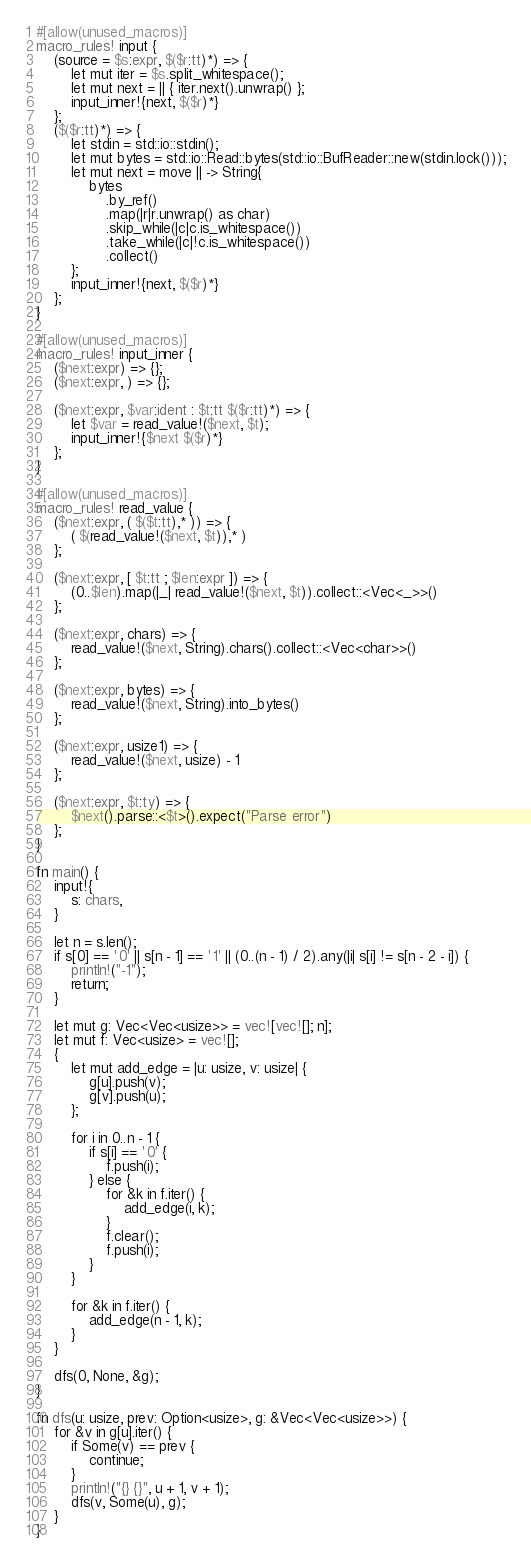<code> <loc_0><loc_0><loc_500><loc_500><_Rust_>#[allow(unused_macros)]
macro_rules! input {
    (source = $s:expr, $($r:tt)*) => {
        let mut iter = $s.split_whitespace();
        let mut next = || { iter.next().unwrap() };
        input_inner!{next, $($r)*}
    };
    ($($r:tt)*) => {
        let stdin = std::io::stdin();
        let mut bytes = std::io::Read::bytes(std::io::BufReader::new(stdin.lock()));
        let mut next = move || -> String{
            bytes
                .by_ref()
                .map(|r|r.unwrap() as char)
                .skip_while(|c|c.is_whitespace())
                .take_while(|c|!c.is_whitespace())
                .collect()
        };
        input_inner!{next, $($r)*}
    };
}

#[allow(unused_macros)]
macro_rules! input_inner {
    ($next:expr) => {};
    ($next:expr, ) => {};

    ($next:expr, $var:ident : $t:tt $($r:tt)*) => {
        let $var = read_value!($next, $t);
        input_inner!{$next $($r)*}
    };
}

#[allow(unused_macros)]
macro_rules! read_value {
    ($next:expr, ( $($t:tt),* )) => {
        ( $(read_value!($next, $t)),* )
    };

    ($next:expr, [ $t:tt ; $len:expr ]) => {
        (0..$len).map(|_| read_value!($next, $t)).collect::<Vec<_>>()
    };

    ($next:expr, chars) => {
        read_value!($next, String).chars().collect::<Vec<char>>()
    };

    ($next:expr, bytes) => {
        read_value!($next, String).into_bytes()
    };

    ($next:expr, usize1) => {
        read_value!($next, usize) - 1
    };

    ($next:expr, $t:ty) => {
        $next().parse::<$t>().expect("Parse error")
    };
}

fn main() {
    input!{
        s: chars,
    }

    let n = s.len();
    if s[0] == '0' || s[n - 1] == '1' || (0..(n - 1) / 2).any(|i| s[i] != s[n - 2 - i]) {
        println!("-1");
        return;
    }

    let mut g: Vec<Vec<usize>> = vec![vec![]; n];
    let mut f: Vec<usize> = vec![];
    {
        let mut add_edge = |u: usize, v: usize| {
            g[u].push(v);
            g[v].push(u);
        };

        for i in 0..n - 1 {
            if s[i] == '0' {
                f.push(i);
            } else {
                for &k in f.iter() {
                    add_edge(i, k);
                }
                f.clear();
                f.push(i);
            }
        }

        for &k in f.iter() {
            add_edge(n - 1, k);
        }
    }

    dfs(0, None, &g);
}

fn dfs(u: usize, prev: Option<usize>, g: &Vec<Vec<usize>>) {
    for &v in g[u].iter() {
        if Some(v) == prev {
            continue;
        }
        println!("{} {}", u + 1, v + 1);
        dfs(v, Some(u), g);
    }
}
</code> 